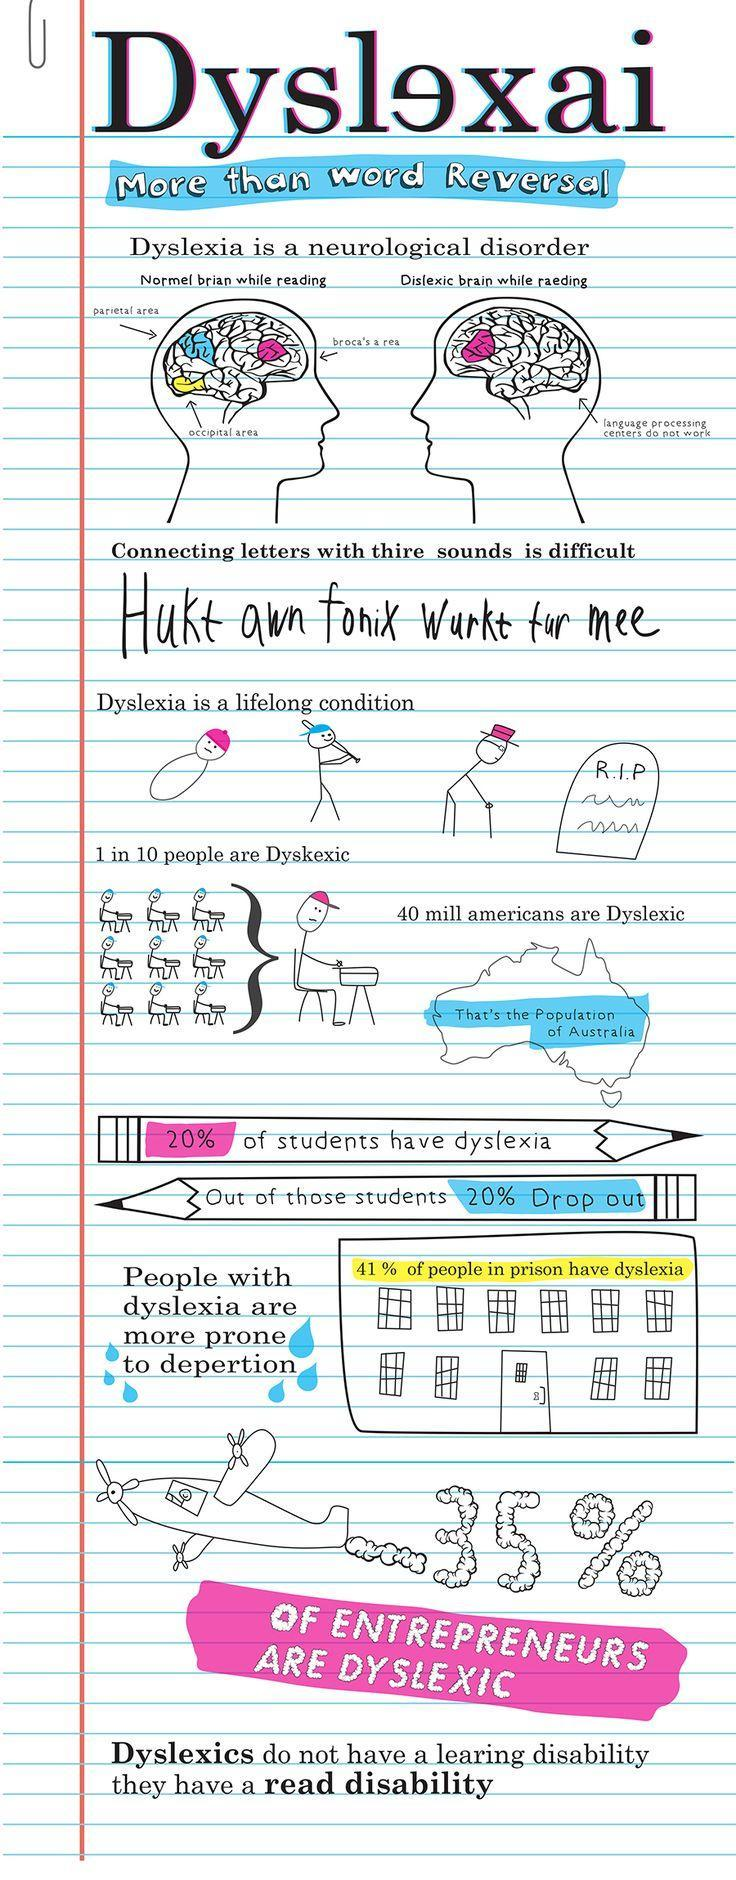Which part of the human brain is shown in blue color?
Answer the question with a short phrase. parietal area What percentage of students do not have dyslexia? 80 How many people out of 10 are not Dyslexic? 9 Which part of the human brain is shown in yellow color? Occipital area Which part of the human brain is shown in magenta color? broca's a rea 